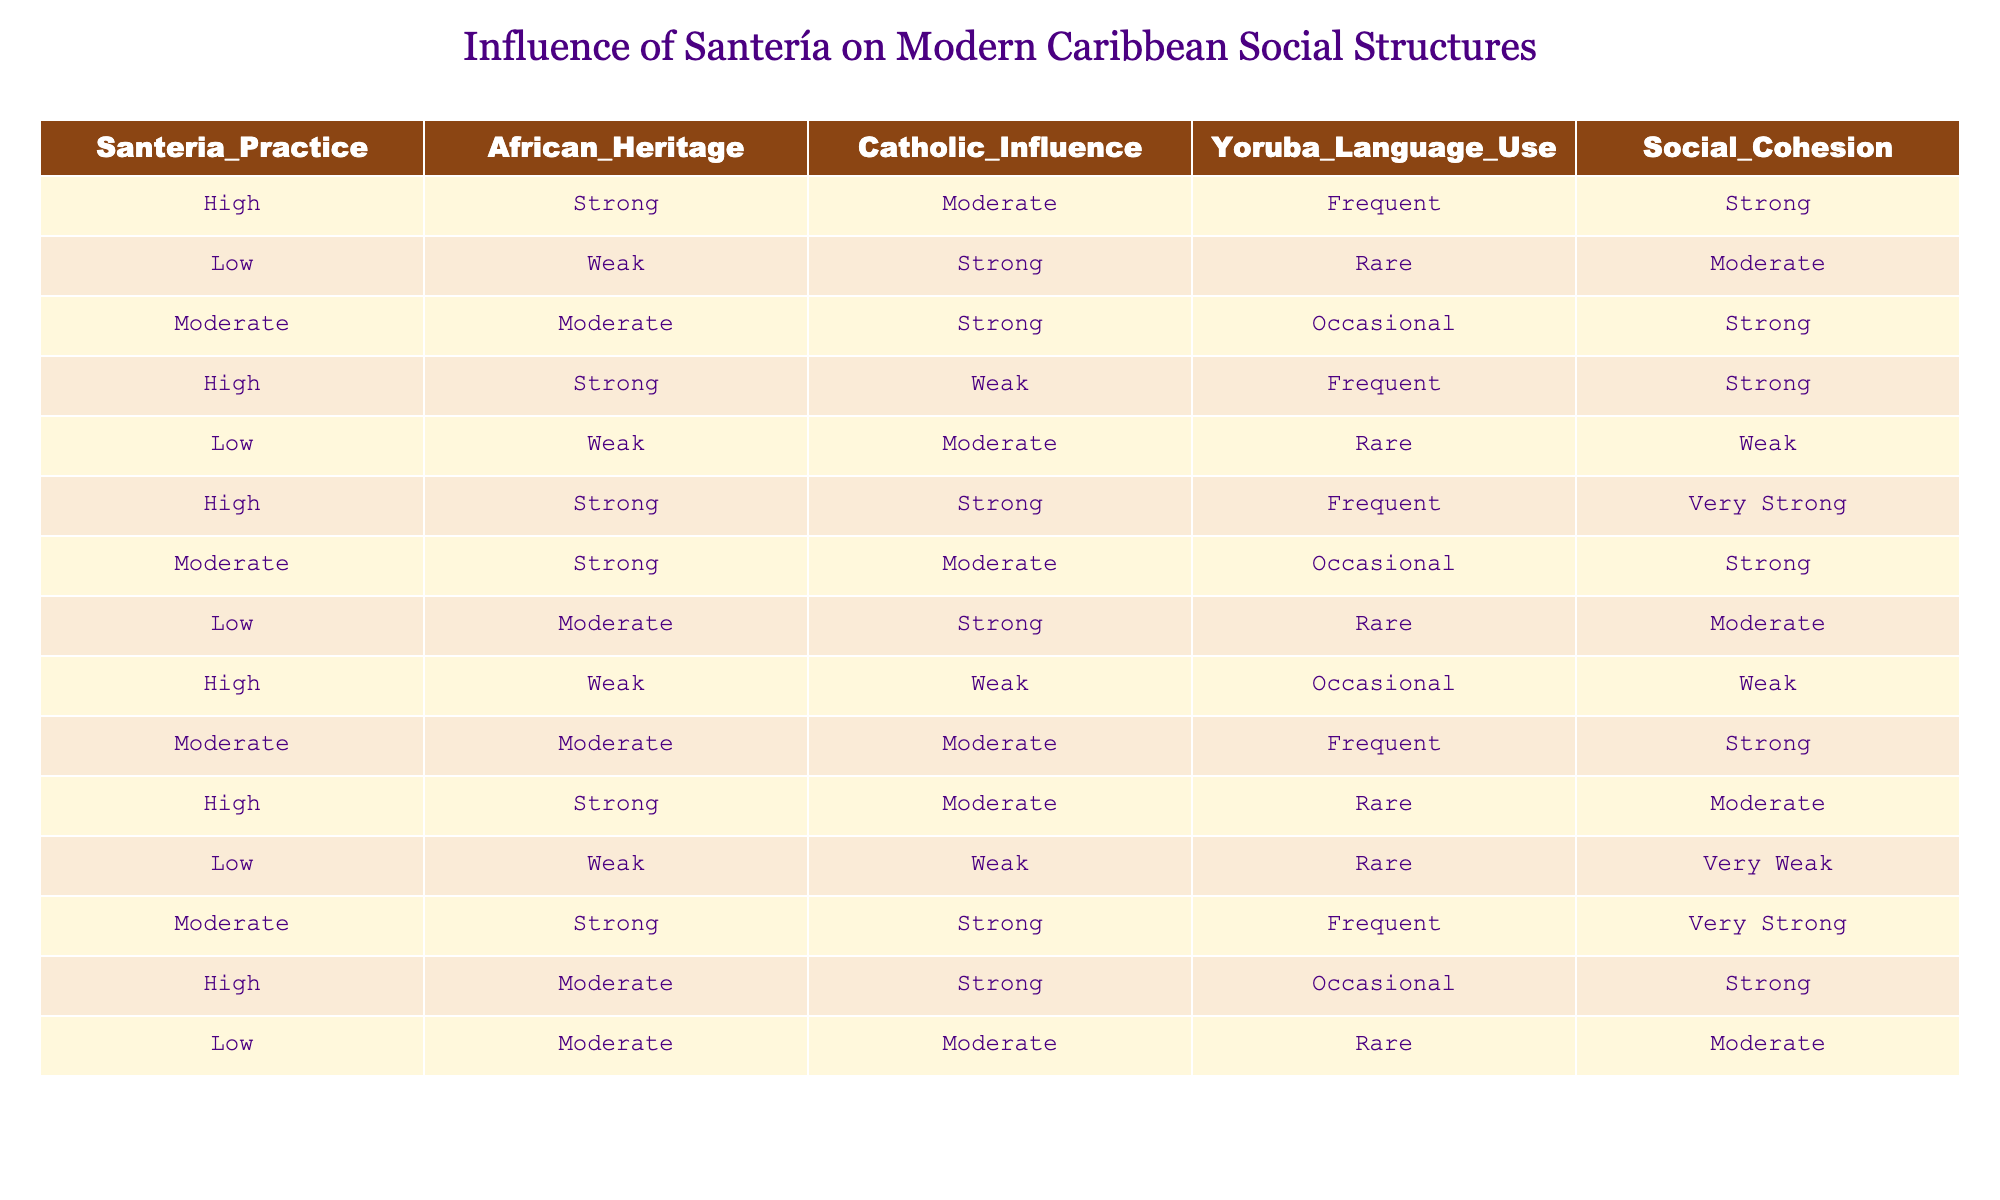What is the social cohesion level for high Santería practice with strong African heritage? In the table, we look for the row that indicates 'High' Santería practice and 'Strong' African heritage. That row shows a social cohesion level of 'Strong.'
Answer: Strong How many rows indicate a weak social cohesion level? By examining the table, we can identify which rows denote a 'Weak' social cohesion. There are two rows with 'Weak' social cohesion levels.
Answer: 2 What is the most common level of African heritage among the entries? In the table, we categorize the entries based on the African heritage column. Counting, we find 'Strong' appears in 6 rows, 'Moderate' in 4 rows, and 'Weak' in 5 rows. Thus, 'Strong' is the most common level.
Answer: Strong Does high Santería practice always correspond to strong social cohesion? Checking each row with 'High' Santería practice, we find that while most indicate strong social cohesion, one entry has a 'Moderate' social cohesion level. Thus, it does not always correspond.
Answer: No What is the average social cohesion level for all entries with low Santería practice? To find the average for low Santería practice, identify the rows with 'Low' practice: they have cohesion levels of 'Moderate,' 'Weak,' and 'Very Weak.' Assigning values: Moderate=3, Weak=2, Very Weak=1, we calculate: (2 + 1 + 3)/3 = 2, which corresponds to an average of 'Weak.'
Answer: Weak 